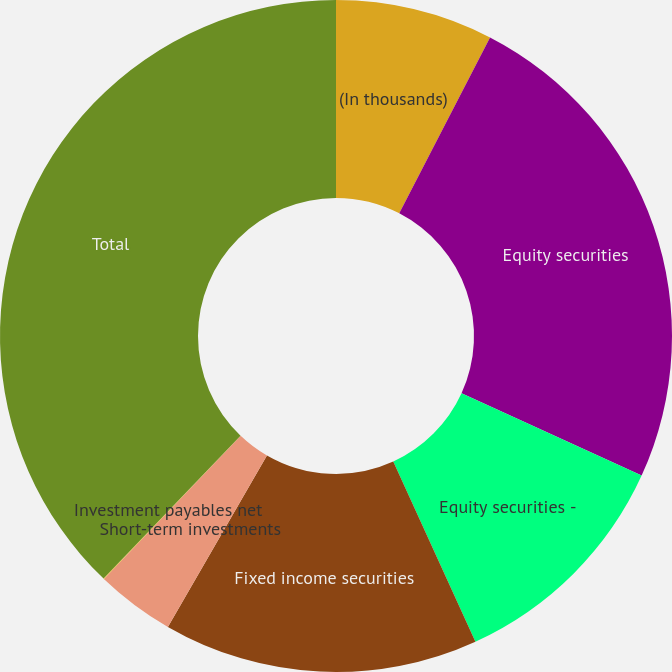Convert chart. <chart><loc_0><loc_0><loc_500><loc_500><pie_chart><fcel>(In thousands)<fcel>Equity securities<fcel>Equity securities -<fcel>Fixed income securities<fcel>Short-term investments<fcel>Investment payables net<fcel>Total<nl><fcel>7.58%<fcel>24.24%<fcel>11.37%<fcel>15.15%<fcel>3.8%<fcel>0.02%<fcel>37.84%<nl></chart> 